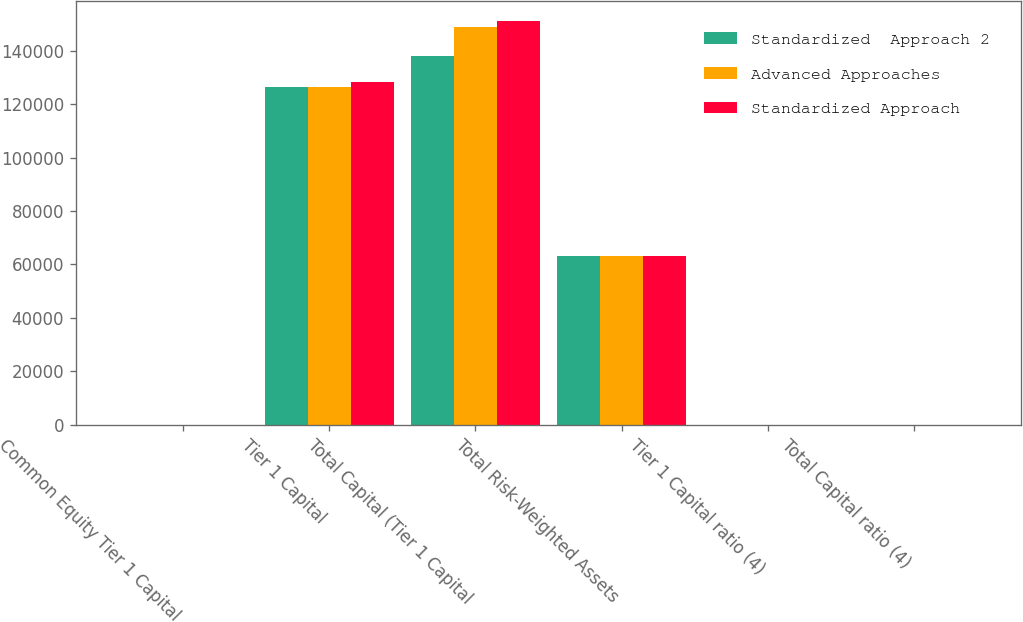Convert chart to OTSL. <chart><loc_0><loc_0><loc_500><loc_500><stacked_bar_chart><ecel><fcel>Common Equity Tier 1 Capital<fcel>Tier 1 Capital<fcel>Total Capital (Tier 1 Capital<fcel>Total Risk-Weighted Assets<fcel>Tier 1 Capital ratio (4)<fcel>Total Capital ratio (4)<nl><fcel>Standardized  Approach 2<fcel>14.09<fcel>126496<fcel>137935<fcel>63255.7<fcel>14.09<fcel>15.36<nl><fcel>Advanced Approaches<fcel>12.67<fcel>126496<fcel>148916<fcel>63255.7<fcel>12.67<fcel>14.92<nl><fcel>Standardized Approach<fcel>12.28<fcel>128262<fcel>151124<fcel>63255.7<fcel>12.28<fcel>14.46<nl></chart> 